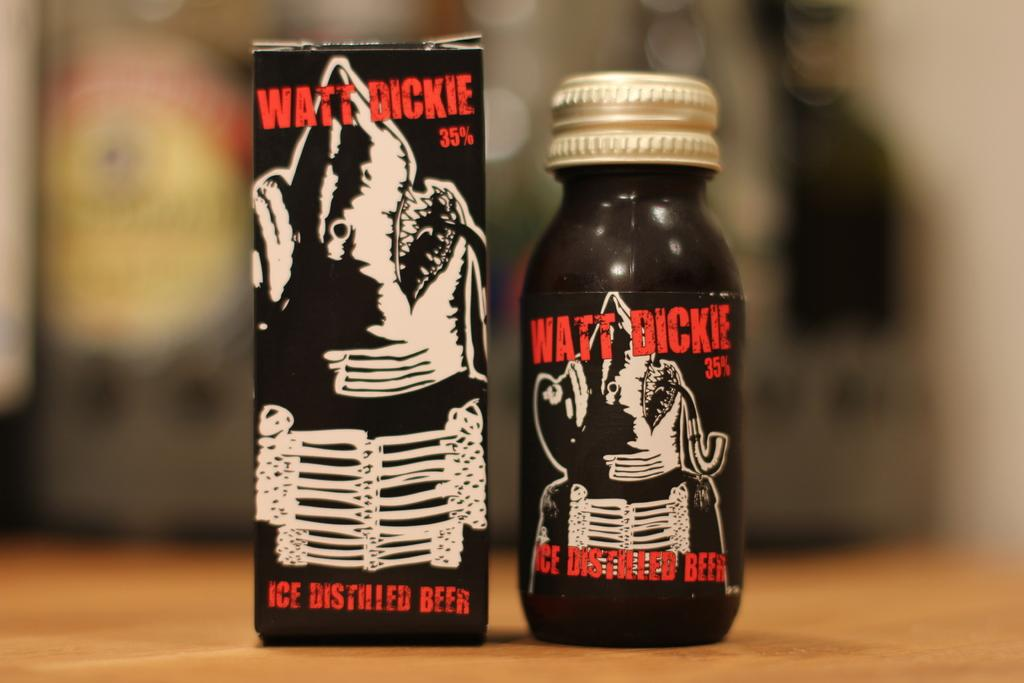<image>
Summarize the visual content of the image. Matt Dickie distilled beer box sitting next to a small container of the beer. 